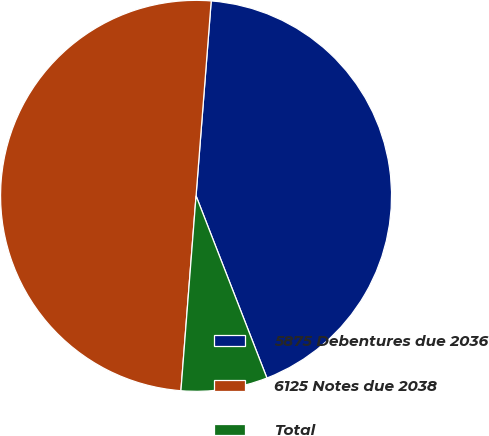Convert chart to OTSL. <chart><loc_0><loc_0><loc_500><loc_500><pie_chart><fcel>5875 Debentures due 2036<fcel>6125 Notes due 2038<fcel>Total<nl><fcel>42.86%<fcel>50.0%<fcel>7.14%<nl></chart> 